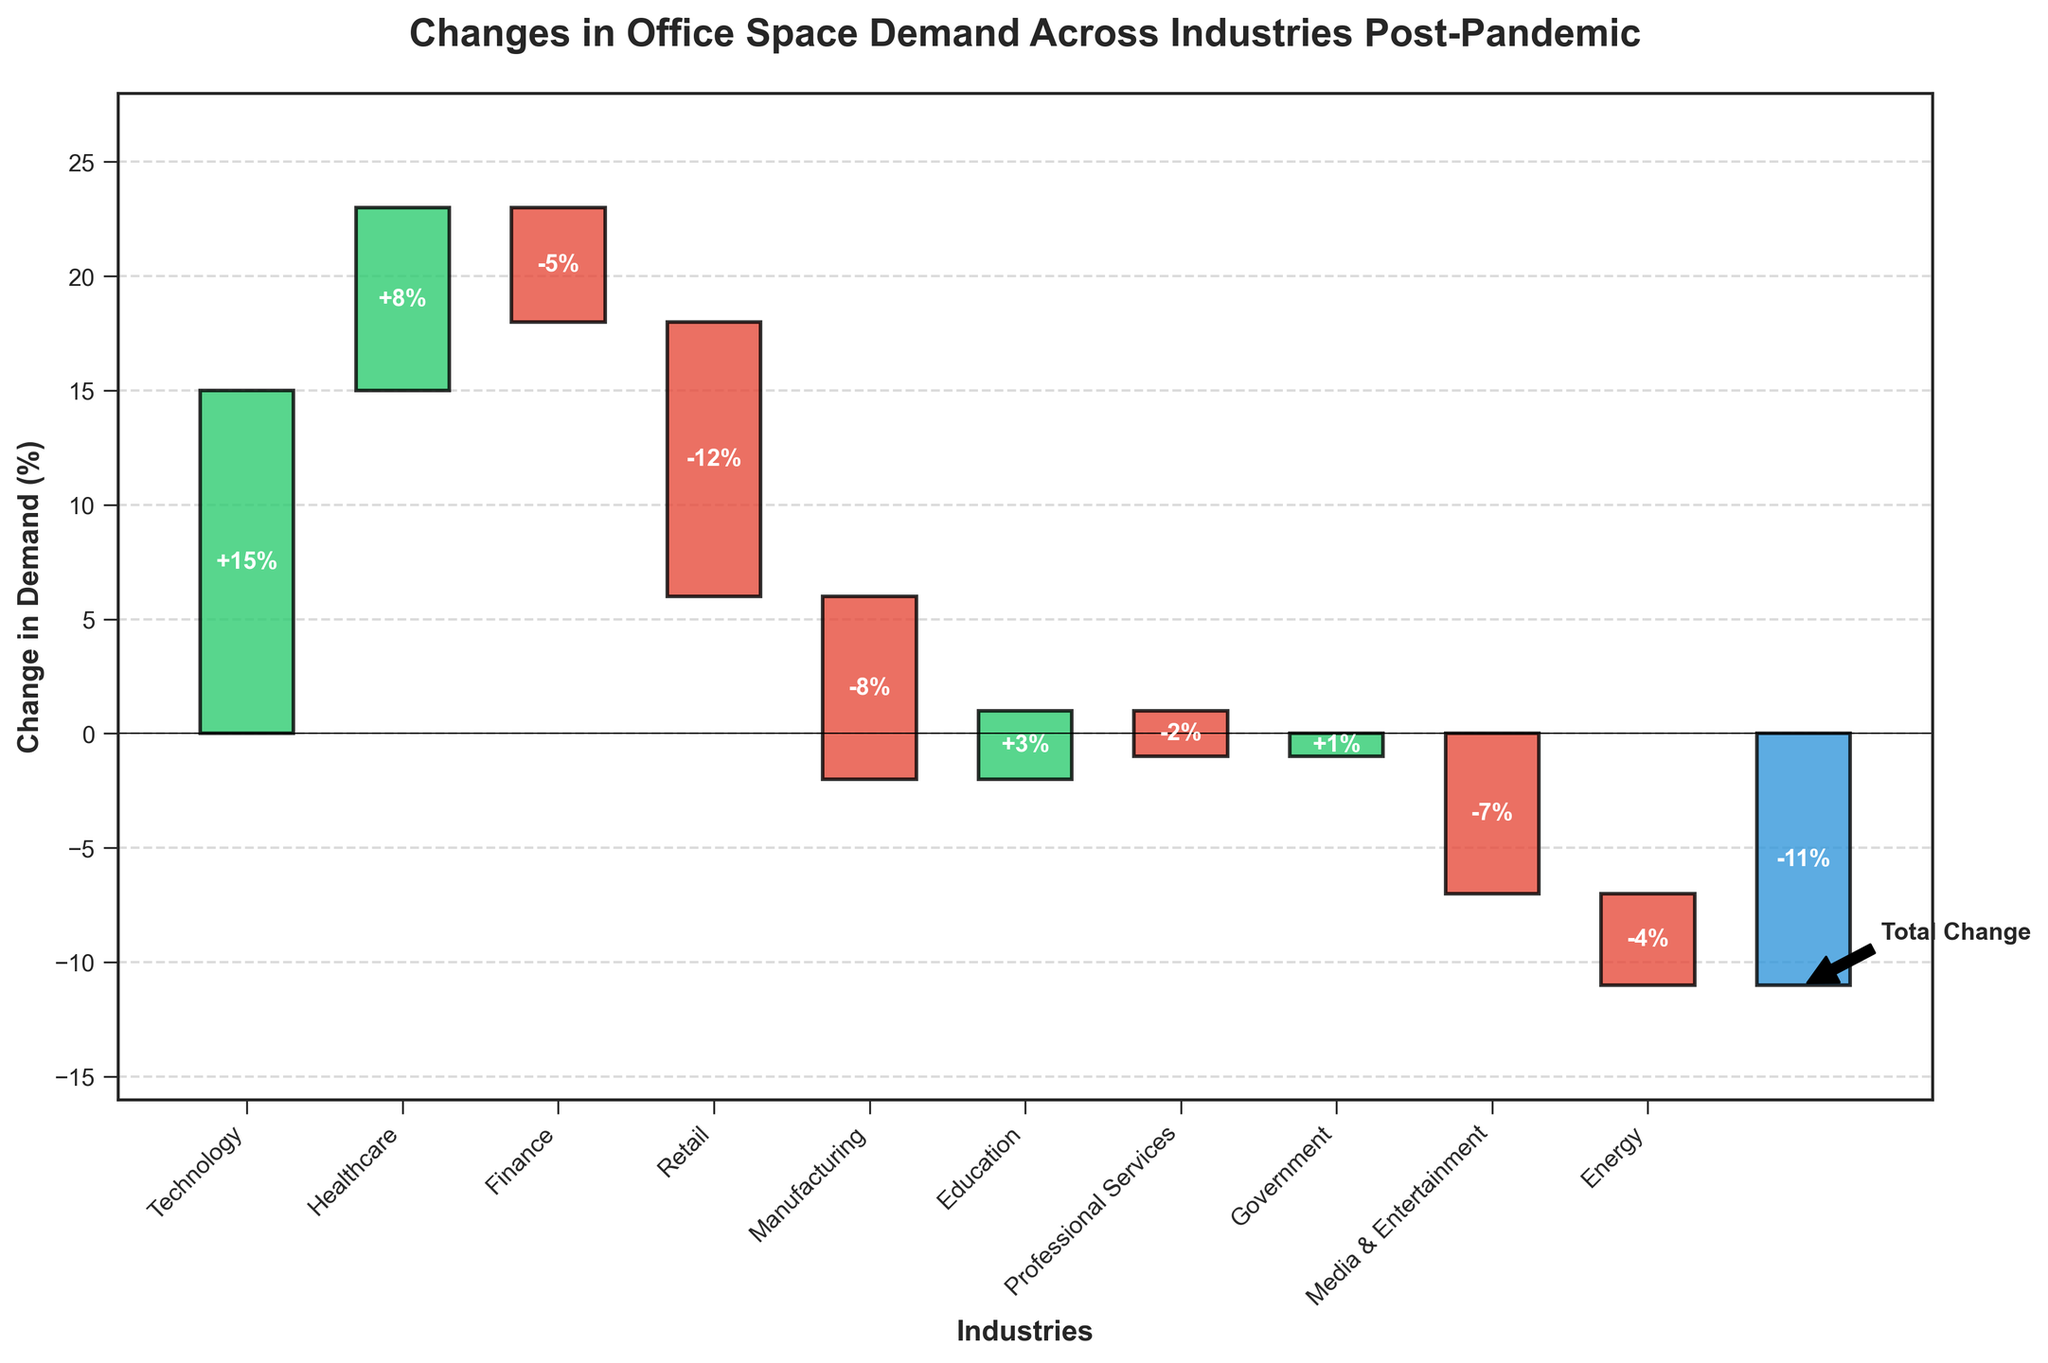What is the title of the chart? The title is located at the top of the figure, indicating what is being represented.
Answer: Changes in Office Space Demand Across Industries Post-Pandemic How many industries are analyzed in the chart excluding the total change? There are ten bars representing the individual industries before the final bar for the total change.
Answer: 10 Which industry saw the highest increase in demand for office space? Compare the heights of all the positive bars; the tallest one represents the highest increase.
Answer: Technology What is the overall total change in office space demand across all industries? The last bar represents the total change in demand for office space across all industries.
Answer: -11% How does the change in demand for office space in the Finance industry compare to that in the Retail industry? The change in the Finance industry is -5%, and the change in the Retail industry is -12%; thus, Finance had a smaller decrease.
Answer: Finance has a smaller decrease What is the cumulative change after the first three industries? Sum the changes for Technology (15%), Healthcare (8%), and Finance (-5%).
Answer: 18% Which industry experienced the smallest change in office space demand, whether positive or negative? Identify the bar closest to the x-axis (0% change).
Answer: Government Between Manufacturing and Media & Entertainment, which industry saw a greater decrease in demand? Compare their respective changes: Manufacturing (-8%) and Media & Entertainment (-7%).
Answer: Manufacturing What is the average change in demand across all the industries excluding the total change? Sum all the changes and divide by the number of industries: (15+8-5-12-8+3-2+1-7-4)/10.
Answer: -1.7% Summarize the changes in Healthcare and Professional Services industries. Healthcare increased by 8%, and Professional Services decreased by 2%. Combining these gives the net effect of +6%.
Answer: Healthcare increased, Professional Services decreased 